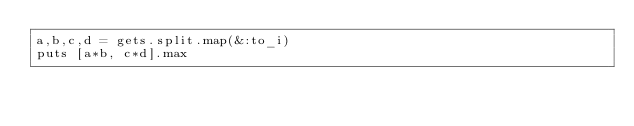<code> <loc_0><loc_0><loc_500><loc_500><_Ruby_>a,b,c,d = gets.split.map(&:to_i)
puts [a*b, c*d].max</code> 